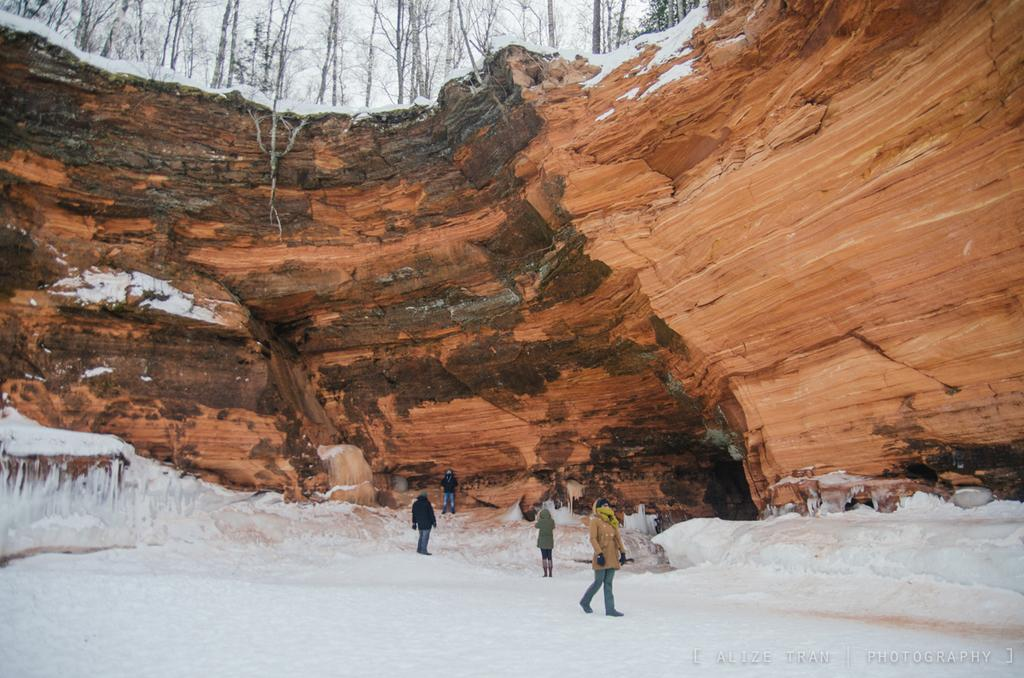What are the people in the image doing? The people in the image are standing and walking on the snow. What is the large object in the image? There is a big rock in the image. What type of vegetation is near the rock? Trees are present near the rock. What type of event is taking place in the yard with the doll in the image? There is no yard or doll present in the image; it features people standing and walking on the snow with a big rock and trees nearby. 